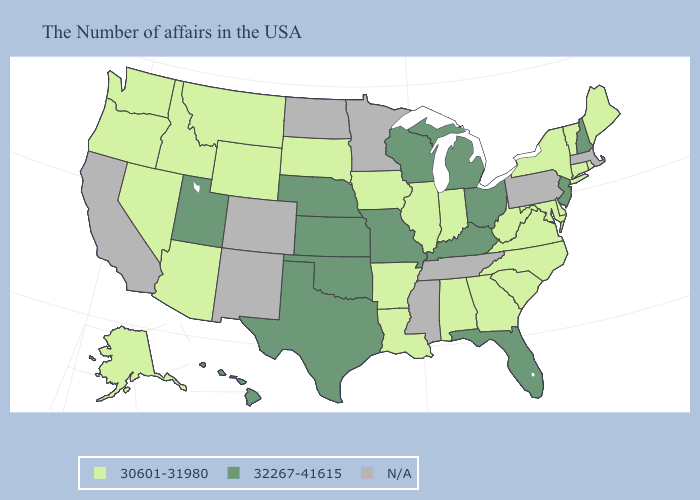Name the states that have a value in the range 32267-41615?
Write a very short answer. New Hampshire, New Jersey, Ohio, Florida, Michigan, Kentucky, Wisconsin, Missouri, Kansas, Nebraska, Oklahoma, Texas, Utah, Hawaii. Does the map have missing data?
Quick response, please. Yes. Name the states that have a value in the range 32267-41615?
Concise answer only. New Hampshire, New Jersey, Ohio, Florida, Michigan, Kentucky, Wisconsin, Missouri, Kansas, Nebraska, Oklahoma, Texas, Utah, Hawaii. Name the states that have a value in the range 30601-31980?
Answer briefly. Maine, Rhode Island, Vermont, Connecticut, New York, Delaware, Maryland, Virginia, North Carolina, South Carolina, West Virginia, Georgia, Indiana, Alabama, Illinois, Louisiana, Arkansas, Iowa, South Dakota, Wyoming, Montana, Arizona, Idaho, Nevada, Washington, Oregon, Alaska. Does the map have missing data?
Give a very brief answer. Yes. What is the lowest value in the USA?
Answer briefly. 30601-31980. What is the value of New Mexico?
Answer briefly. N/A. Name the states that have a value in the range 32267-41615?
Keep it brief. New Hampshire, New Jersey, Ohio, Florida, Michigan, Kentucky, Wisconsin, Missouri, Kansas, Nebraska, Oklahoma, Texas, Utah, Hawaii. Does West Virginia have the lowest value in the USA?
Give a very brief answer. Yes. Name the states that have a value in the range 30601-31980?
Quick response, please. Maine, Rhode Island, Vermont, Connecticut, New York, Delaware, Maryland, Virginia, North Carolina, South Carolina, West Virginia, Georgia, Indiana, Alabama, Illinois, Louisiana, Arkansas, Iowa, South Dakota, Wyoming, Montana, Arizona, Idaho, Nevada, Washington, Oregon, Alaska. What is the value of Washington?
Give a very brief answer. 30601-31980. How many symbols are there in the legend?
Short answer required. 3. Among the states that border Indiana , which have the lowest value?
Short answer required. Illinois. Name the states that have a value in the range N/A?
Answer briefly. Massachusetts, Pennsylvania, Tennessee, Mississippi, Minnesota, North Dakota, Colorado, New Mexico, California. 